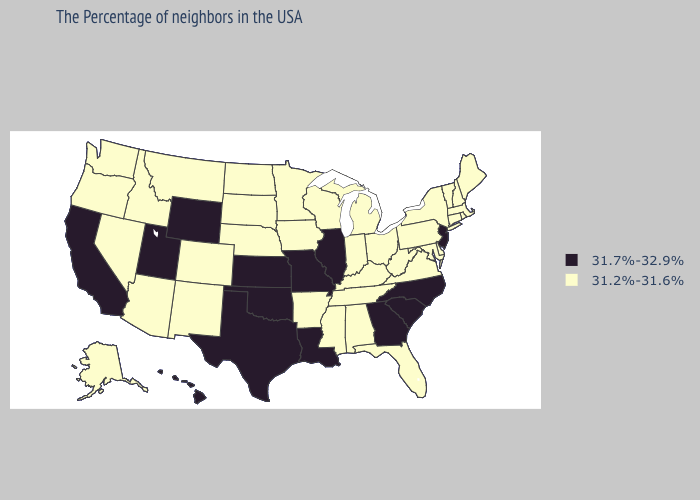Among the states that border Arkansas , does Tennessee have the highest value?
Answer briefly. No. Does the map have missing data?
Concise answer only. No. Among the states that border New York , which have the highest value?
Concise answer only. New Jersey. What is the value of Utah?
Write a very short answer. 31.7%-32.9%. Which states have the lowest value in the MidWest?
Be succinct. Ohio, Michigan, Indiana, Wisconsin, Minnesota, Iowa, Nebraska, South Dakota, North Dakota. Name the states that have a value in the range 31.2%-31.6%?
Concise answer only. Maine, Massachusetts, Rhode Island, New Hampshire, Vermont, Connecticut, New York, Delaware, Maryland, Pennsylvania, Virginia, West Virginia, Ohio, Florida, Michigan, Kentucky, Indiana, Alabama, Tennessee, Wisconsin, Mississippi, Arkansas, Minnesota, Iowa, Nebraska, South Dakota, North Dakota, Colorado, New Mexico, Montana, Arizona, Idaho, Nevada, Washington, Oregon, Alaska. What is the highest value in the South ?
Give a very brief answer. 31.7%-32.9%. What is the highest value in the USA?
Short answer required. 31.7%-32.9%. Is the legend a continuous bar?
Give a very brief answer. No. Among the states that border Indiana , which have the lowest value?
Quick response, please. Ohio, Michigan, Kentucky. Which states have the highest value in the USA?
Quick response, please. New Jersey, North Carolina, South Carolina, Georgia, Illinois, Louisiana, Missouri, Kansas, Oklahoma, Texas, Wyoming, Utah, California, Hawaii. Name the states that have a value in the range 31.2%-31.6%?
Short answer required. Maine, Massachusetts, Rhode Island, New Hampshire, Vermont, Connecticut, New York, Delaware, Maryland, Pennsylvania, Virginia, West Virginia, Ohio, Florida, Michigan, Kentucky, Indiana, Alabama, Tennessee, Wisconsin, Mississippi, Arkansas, Minnesota, Iowa, Nebraska, South Dakota, North Dakota, Colorado, New Mexico, Montana, Arizona, Idaho, Nevada, Washington, Oregon, Alaska. 